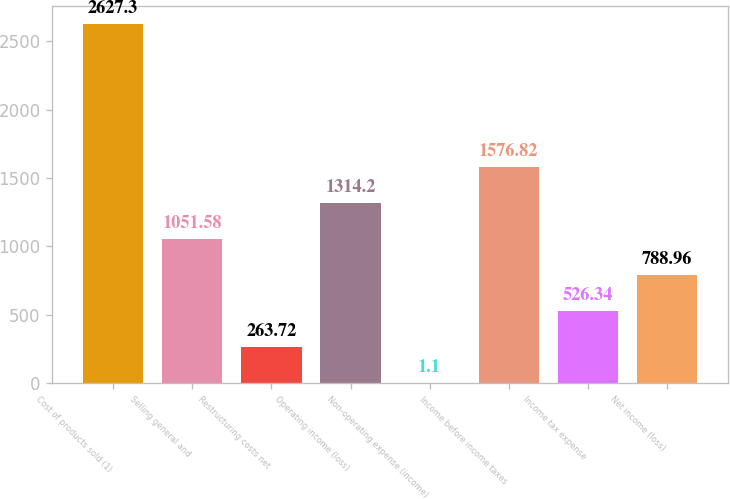Convert chart. <chart><loc_0><loc_0><loc_500><loc_500><bar_chart><fcel>Cost of products sold (1)<fcel>Selling general and<fcel>Restructuring costs net<fcel>Operating income (loss)<fcel>Non-operating expense (income)<fcel>Income before income taxes<fcel>Income tax expense<fcel>Net income (loss)<nl><fcel>2627.3<fcel>1051.58<fcel>263.72<fcel>1314.2<fcel>1.1<fcel>1576.82<fcel>526.34<fcel>788.96<nl></chart> 